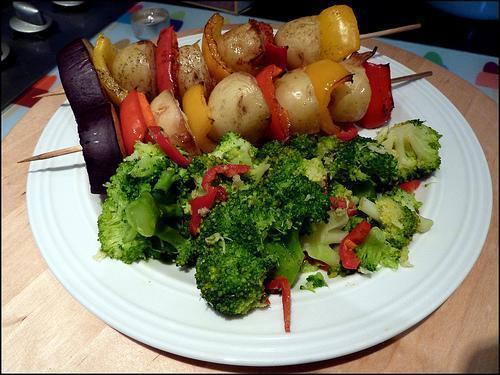How many types of vegetable are shown?
Give a very brief answer. 5. 